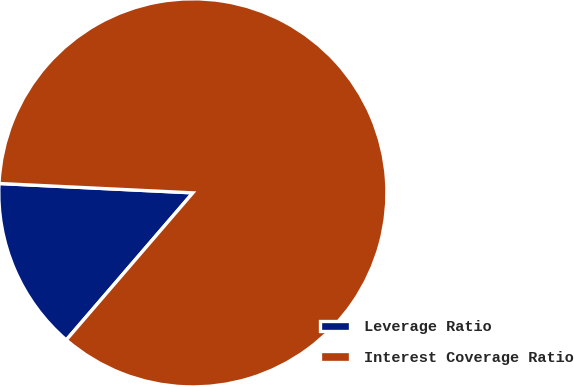<chart> <loc_0><loc_0><loc_500><loc_500><pie_chart><fcel>Leverage Ratio<fcel>Interest Coverage Ratio<nl><fcel>14.46%<fcel>85.54%<nl></chart> 